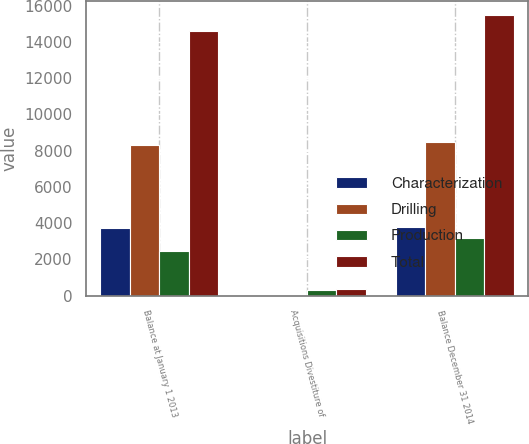<chart> <loc_0><loc_0><loc_500><loc_500><stacked_bar_chart><ecel><fcel>Balance at January 1 2013<fcel>Acquisitions Divestiture of<fcel>Balance December 31 2014<nl><fcel>Characterization<fcel>3760<fcel>4<fcel>3812<nl><fcel>Drilling<fcel>8337<fcel>3<fcel>8488<nl><fcel>Production<fcel>2488<fcel>336<fcel>3187<nl><fcel>Total<fcel>14585<fcel>343<fcel>15487<nl></chart> 